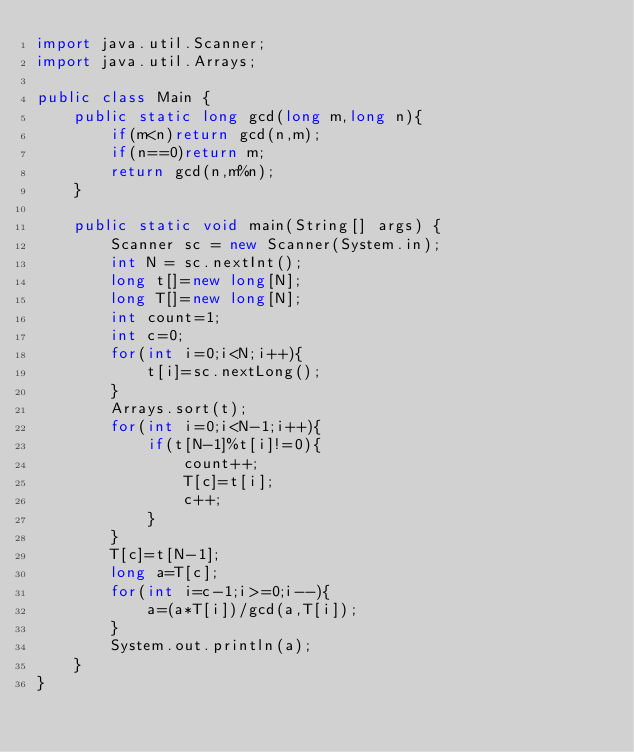<code> <loc_0><loc_0><loc_500><loc_500><_Java_>import java.util.Scanner;
import java.util.Arrays;

public class Main {
    public static long gcd(long m,long n){
        if(m<n)return gcd(n,m);
        if(n==0)return m;
        return gcd(n,m%n);
    }

    public static void main(String[] args) {
        Scanner sc = new Scanner(System.in);
        int N = sc.nextInt();
        long t[]=new long[N];
        long T[]=new long[N];
        int count=1;
        int c=0;
        for(int i=0;i<N;i++){
            t[i]=sc.nextLong();
        }
        Arrays.sort(t);
        for(int i=0;i<N-1;i++){
            if(t[N-1]%t[i]!=0){
                count++;
                T[c]=t[i];
                c++;
            }
        }
        T[c]=t[N-1];
        long a=T[c];
        for(int i=c-1;i>=0;i--){
            a=(a*T[i])/gcd(a,T[i]);
        }
        System.out.println(a);
    }
}</code> 